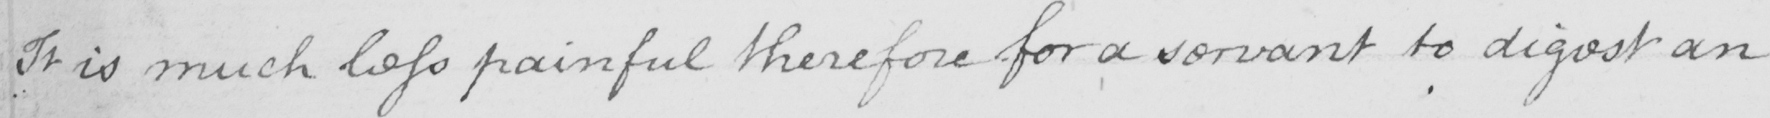What is written in this line of handwriting? It is much less painful therefore for a servant to digest an 